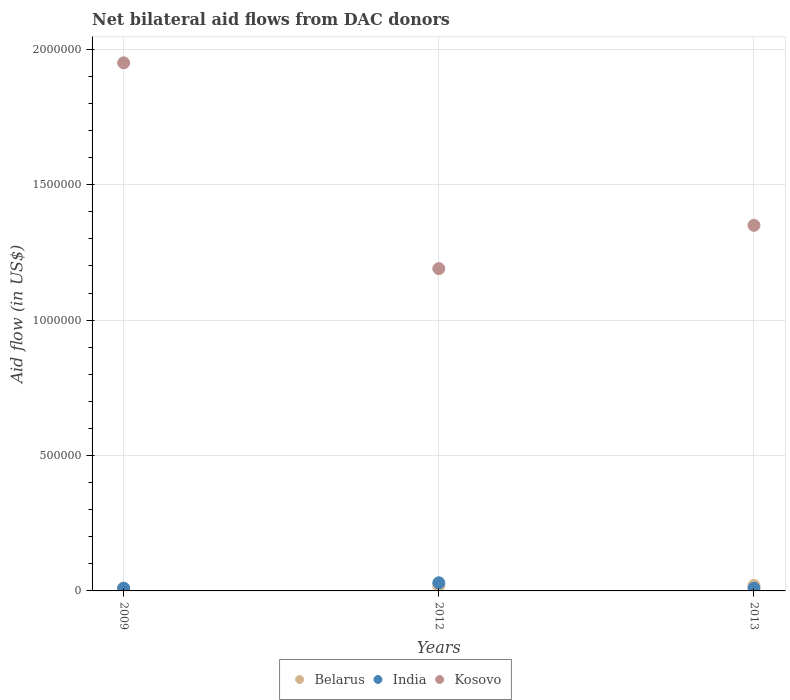Is the number of dotlines equal to the number of legend labels?
Ensure brevity in your answer.  Yes. What is the net bilateral aid flow in Belarus in 2013?
Ensure brevity in your answer.  2.00e+04. Across all years, what is the maximum net bilateral aid flow in India?
Ensure brevity in your answer.  3.00e+04. Across all years, what is the minimum net bilateral aid flow in Belarus?
Make the answer very short. 10000. In which year was the net bilateral aid flow in Belarus maximum?
Keep it short and to the point. 2012. In which year was the net bilateral aid flow in Kosovo minimum?
Your answer should be compact. 2012. What is the total net bilateral aid flow in Belarus in the graph?
Offer a very short reply. 5.00e+04. What is the difference between the net bilateral aid flow in India in 2012 and that in 2013?
Make the answer very short. 2.00e+04. What is the difference between the net bilateral aid flow in Belarus in 2012 and the net bilateral aid flow in Kosovo in 2009?
Offer a very short reply. -1.93e+06. What is the average net bilateral aid flow in India per year?
Your response must be concise. 1.67e+04. What is the ratio of the net bilateral aid flow in Kosovo in 2009 to that in 2013?
Your response must be concise. 1.44. Is the difference between the net bilateral aid flow in Belarus in 2009 and 2013 greater than the difference between the net bilateral aid flow in India in 2009 and 2013?
Provide a succinct answer. No. Is it the case that in every year, the sum of the net bilateral aid flow in Kosovo and net bilateral aid flow in Belarus  is greater than the net bilateral aid flow in India?
Your answer should be very brief. Yes. Is the net bilateral aid flow in Kosovo strictly less than the net bilateral aid flow in India over the years?
Ensure brevity in your answer.  No. How many years are there in the graph?
Keep it short and to the point. 3. What is the difference between two consecutive major ticks on the Y-axis?
Provide a succinct answer. 5.00e+05. Are the values on the major ticks of Y-axis written in scientific E-notation?
Make the answer very short. No. Does the graph contain any zero values?
Give a very brief answer. No. Does the graph contain grids?
Give a very brief answer. Yes. Where does the legend appear in the graph?
Your answer should be very brief. Bottom center. How many legend labels are there?
Ensure brevity in your answer.  3. How are the legend labels stacked?
Ensure brevity in your answer.  Horizontal. What is the title of the graph?
Your response must be concise. Net bilateral aid flows from DAC donors. What is the label or title of the X-axis?
Ensure brevity in your answer.  Years. What is the label or title of the Y-axis?
Your response must be concise. Aid flow (in US$). What is the Aid flow (in US$) of Kosovo in 2009?
Keep it short and to the point. 1.95e+06. What is the Aid flow (in US$) of Belarus in 2012?
Your response must be concise. 2.00e+04. What is the Aid flow (in US$) in Kosovo in 2012?
Offer a terse response. 1.19e+06. What is the Aid flow (in US$) in Kosovo in 2013?
Ensure brevity in your answer.  1.35e+06. Across all years, what is the maximum Aid flow (in US$) of Kosovo?
Your answer should be compact. 1.95e+06. Across all years, what is the minimum Aid flow (in US$) in India?
Provide a succinct answer. 10000. Across all years, what is the minimum Aid flow (in US$) of Kosovo?
Make the answer very short. 1.19e+06. What is the total Aid flow (in US$) in Belarus in the graph?
Ensure brevity in your answer.  5.00e+04. What is the total Aid flow (in US$) of India in the graph?
Make the answer very short. 5.00e+04. What is the total Aid flow (in US$) in Kosovo in the graph?
Offer a terse response. 4.49e+06. What is the difference between the Aid flow (in US$) in Kosovo in 2009 and that in 2012?
Offer a very short reply. 7.60e+05. What is the difference between the Aid flow (in US$) in Kosovo in 2009 and that in 2013?
Keep it short and to the point. 6.00e+05. What is the difference between the Aid flow (in US$) in Belarus in 2009 and the Aid flow (in US$) in Kosovo in 2012?
Your answer should be compact. -1.18e+06. What is the difference between the Aid flow (in US$) in India in 2009 and the Aid flow (in US$) in Kosovo in 2012?
Your answer should be compact. -1.18e+06. What is the difference between the Aid flow (in US$) in Belarus in 2009 and the Aid flow (in US$) in India in 2013?
Your answer should be very brief. 0. What is the difference between the Aid flow (in US$) in Belarus in 2009 and the Aid flow (in US$) in Kosovo in 2013?
Your answer should be compact. -1.34e+06. What is the difference between the Aid flow (in US$) in India in 2009 and the Aid flow (in US$) in Kosovo in 2013?
Provide a short and direct response. -1.34e+06. What is the difference between the Aid flow (in US$) of Belarus in 2012 and the Aid flow (in US$) of India in 2013?
Give a very brief answer. 10000. What is the difference between the Aid flow (in US$) in Belarus in 2012 and the Aid flow (in US$) in Kosovo in 2013?
Offer a terse response. -1.33e+06. What is the difference between the Aid flow (in US$) of India in 2012 and the Aid flow (in US$) of Kosovo in 2013?
Your answer should be compact. -1.32e+06. What is the average Aid flow (in US$) of Belarus per year?
Make the answer very short. 1.67e+04. What is the average Aid flow (in US$) in India per year?
Keep it short and to the point. 1.67e+04. What is the average Aid flow (in US$) of Kosovo per year?
Provide a short and direct response. 1.50e+06. In the year 2009, what is the difference between the Aid flow (in US$) of Belarus and Aid flow (in US$) of India?
Offer a terse response. 0. In the year 2009, what is the difference between the Aid flow (in US$) of Belarus and Aid flow (in US$) of Kosovo?
Offer a terse response. -1.94e+06. In the year 2009, what is the difference between the Aid flow (in US$) of India and Aid flow (in US$) of Kosovo?
Your answer should be compact. -1.94e+06. In the year 2012, what is the difference between the Aid flow (in US$) of Belarus and Aid flow (in US$) of Kosovo?
Keep it short and to the point. -1.17e+06. In the year 2012, what is the difference between the Aid flow (in US$) in India and Aid flow (in US$) in Kosovo?
Give a very brief answer. -1.16e+06. In the year 2013, what is the difference between the Aid flow (in US$) in Belarus and Aid flow (in US$) in India?
Give a very brief answer. 10000. In the year 2013, what is the difference between the Aid flow (in US$) in Belarus and Aid flow (in US$) in Kosovo?
Your answer should be very brief. -1.33e+06. In the year 2013, what is the difference between the Aid flow (in US$) in India and Aid flow (in US$) in Kosovo?
Keep it short and to the point. -1.34e+06. What is the ratio of the Aid flow (in US$) in Belarus in 2009 to that in 2012?
Your answer should be compact. 0.5. What is the ratio of the Aid flow (in US$) in Kosovo in 2009 to that in 2012?
Give a very brief answer. 1.64. What is the ratio of the Aid flow (in US$) of India in 2009 to that in 2013?
Keep it short and to the point. 1. What is the ratio of the Aid flow (in US$) of Kosovo in 2009 to that in 2013?
Offer a very short reply. 1.44. What is the ratio of the Aid flow (in US$) of Belarus in 2012 to that in 2013?
Offer a terse response. 1. What is the ratio of the Aid flow (in US$) in Kosovo in 2012 to that in 2013?
Give a very brief answer. 0.88. What is the difference between the highest and the second highest Aid flow (in US$) in Belarus?
Your response must be concise. 0. What is the difference between the highest and the lowest Aid flow (in US$) of Belarus?
Provide a succinct answer. 10000. What is the difference between the highest and the lowest Aid flow (in US$) of India?
Make the answer very short. 2.00e+04. What is the difference between the highest and the lowest Aid flow (in US$) of Kosovo?
Ensure brevity in your answer.  7.60e+05. 